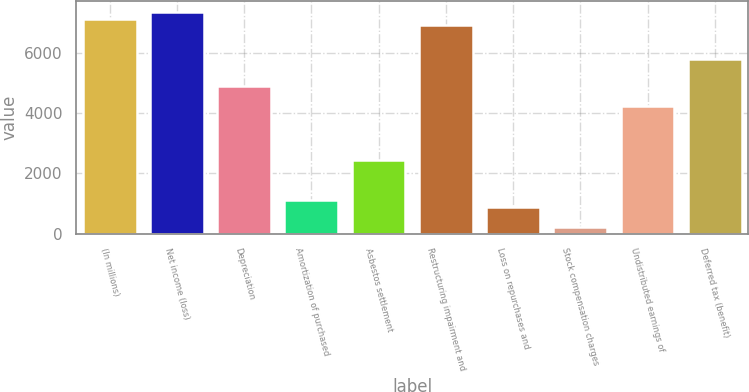Convert chart to OTSL. <chart><loc_0><loc_0><loc_500><loc_500><bar_chart><fcel>(In millions)<fcel>Net income (loss)<fcel>Depreciation<fcel>Amortization of purchased<fcel>Asbestos settlement<fcel>Restructuring impairment and<fcel>Loss on repurchases and<fcel>Stock compensation charges<fcel>Undistributed earnings of<fcel>Deferred tax (benefit)<nl><fcel>7123.8<fcel>7346.2<fcel>4899.8<fcel>1119<fcel>2453.4<fcel>6901.4<fcel>896.6<fcel>229.4<fcel>4232.6<fcel>5789.4<nl></chart> 